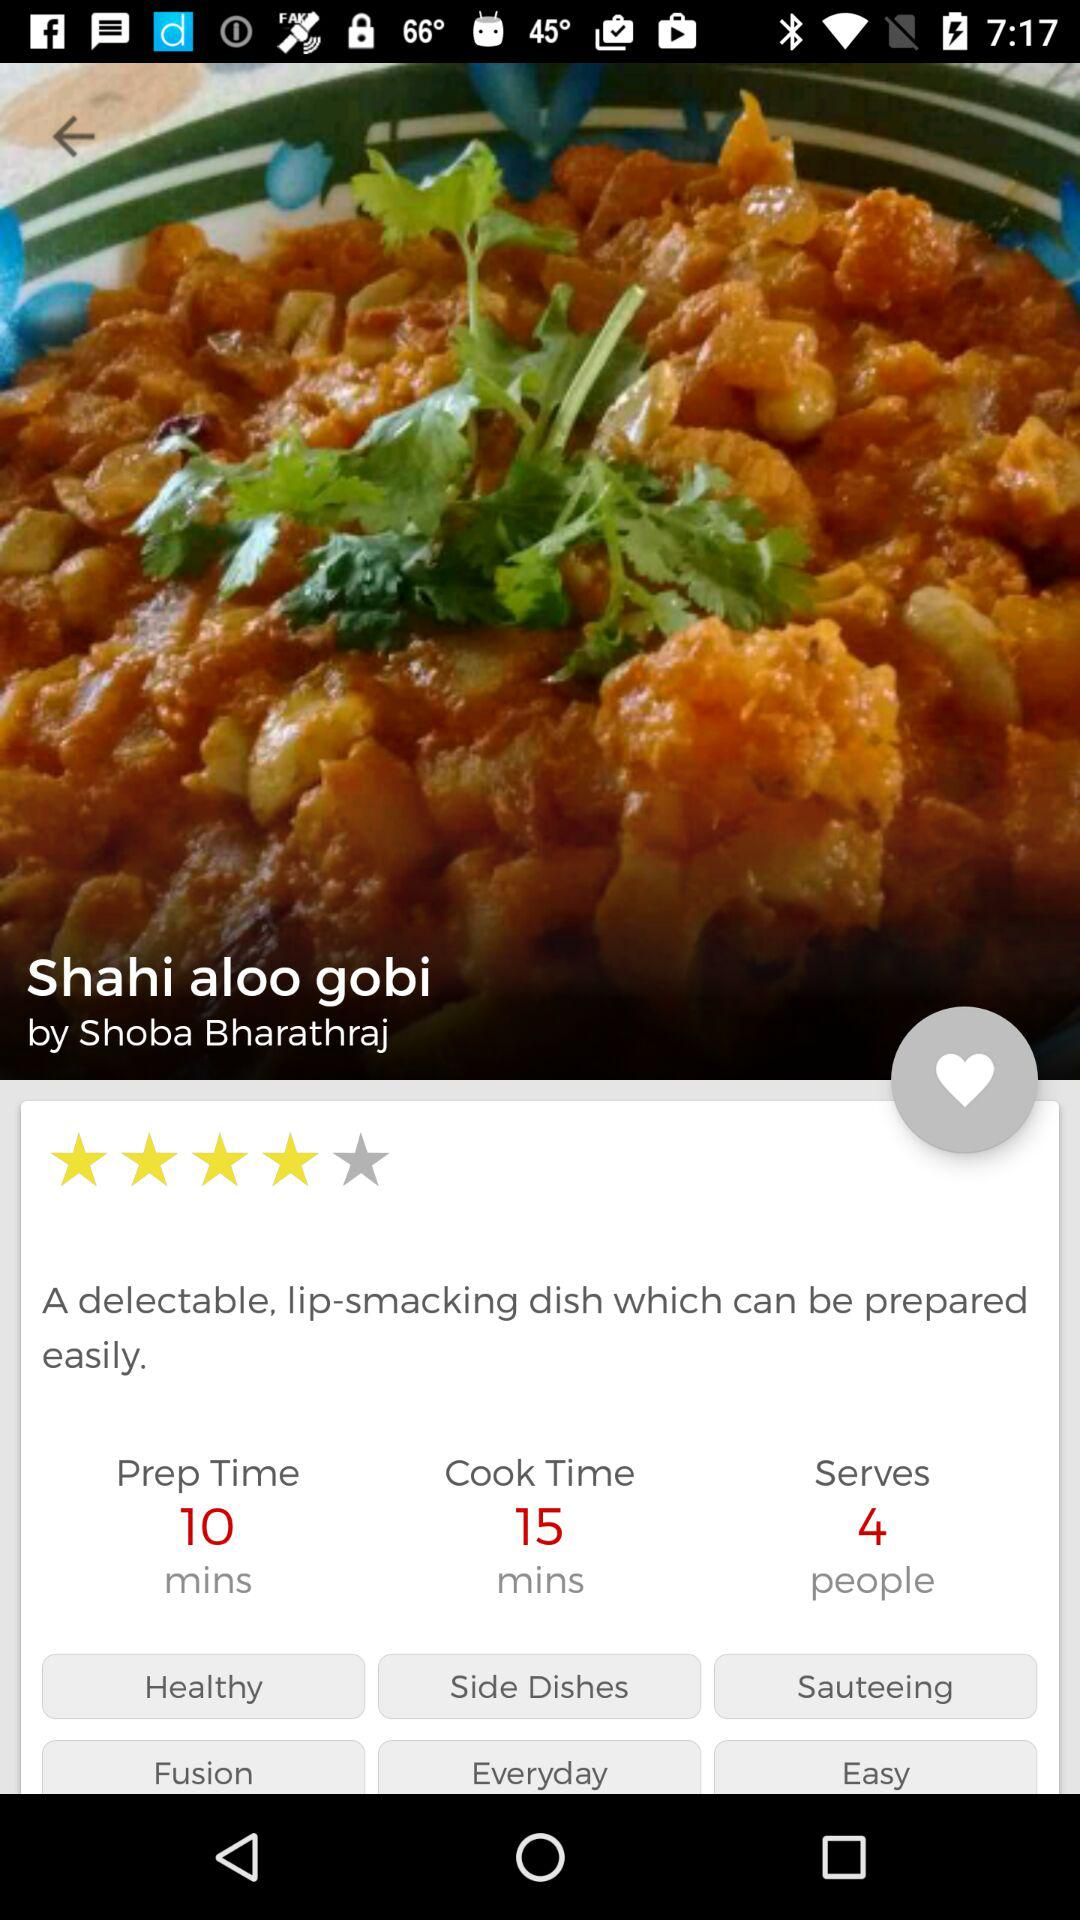How many people can the "Shahi aloo gobi" be served to? The "Shahi aloo gobi" can be served to 4 people. 